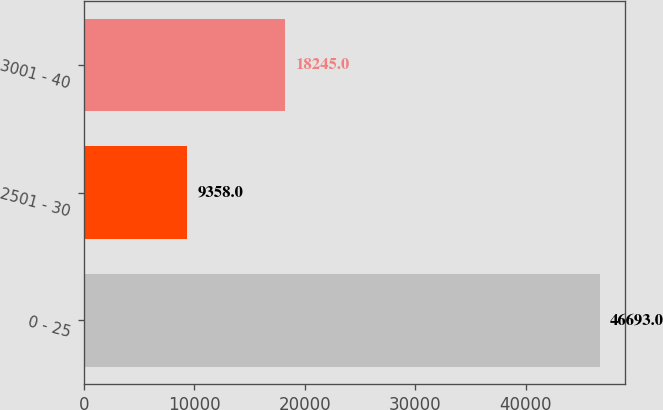<chart> <loc_0><loc_0><loc_500><loc_500><bar_chart><fcel>0 - 25<fcel>2501 - 30<fcel>3001 - 40<nl><fcel>46693<fcel>9358<fcel>18245<nl></chart> 